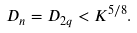Convert formula to latex. <formula><loc_0><loc_0><loc_500><loc_500>D _ { n } = D _ { 2 q } < K ^ { 5 / 8 } .</formula> 